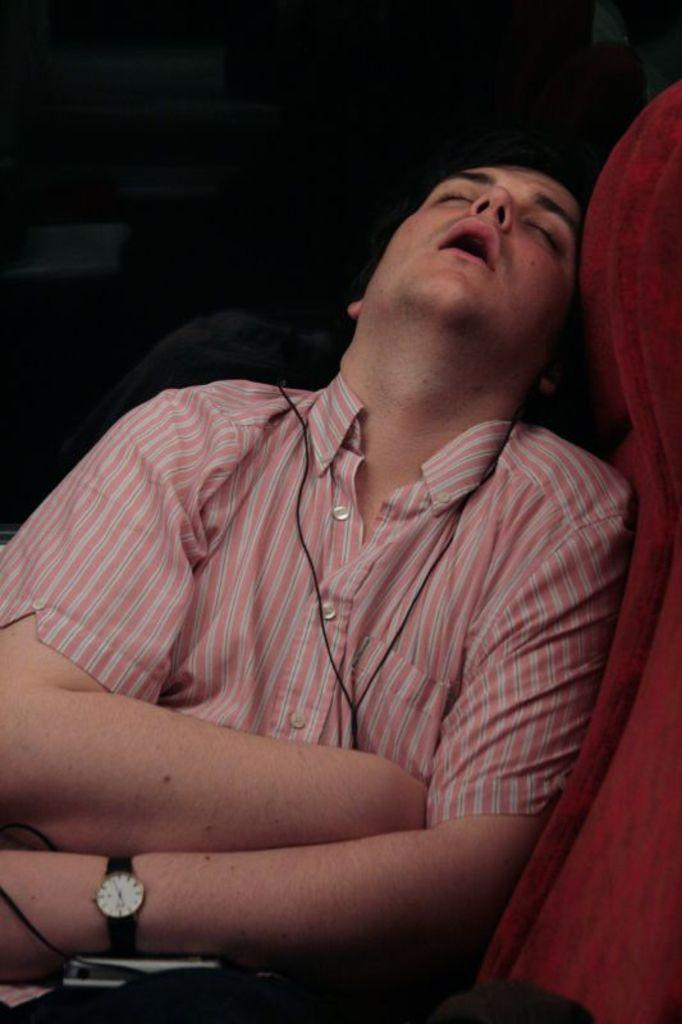Who or what is the main subject in the image? There is a person in the image. What is the person wearing? The person is wearing a pink dress. What is the person doing in the image? The person is sitting on a chair. Can you describe the chair? The chair is red in color. What is the color of the background in the image? The background of the image is black. What type of peace is being negotiated by the person in the image? There is no indication in the image that the person is negotiating peace or any other political or social issue. 